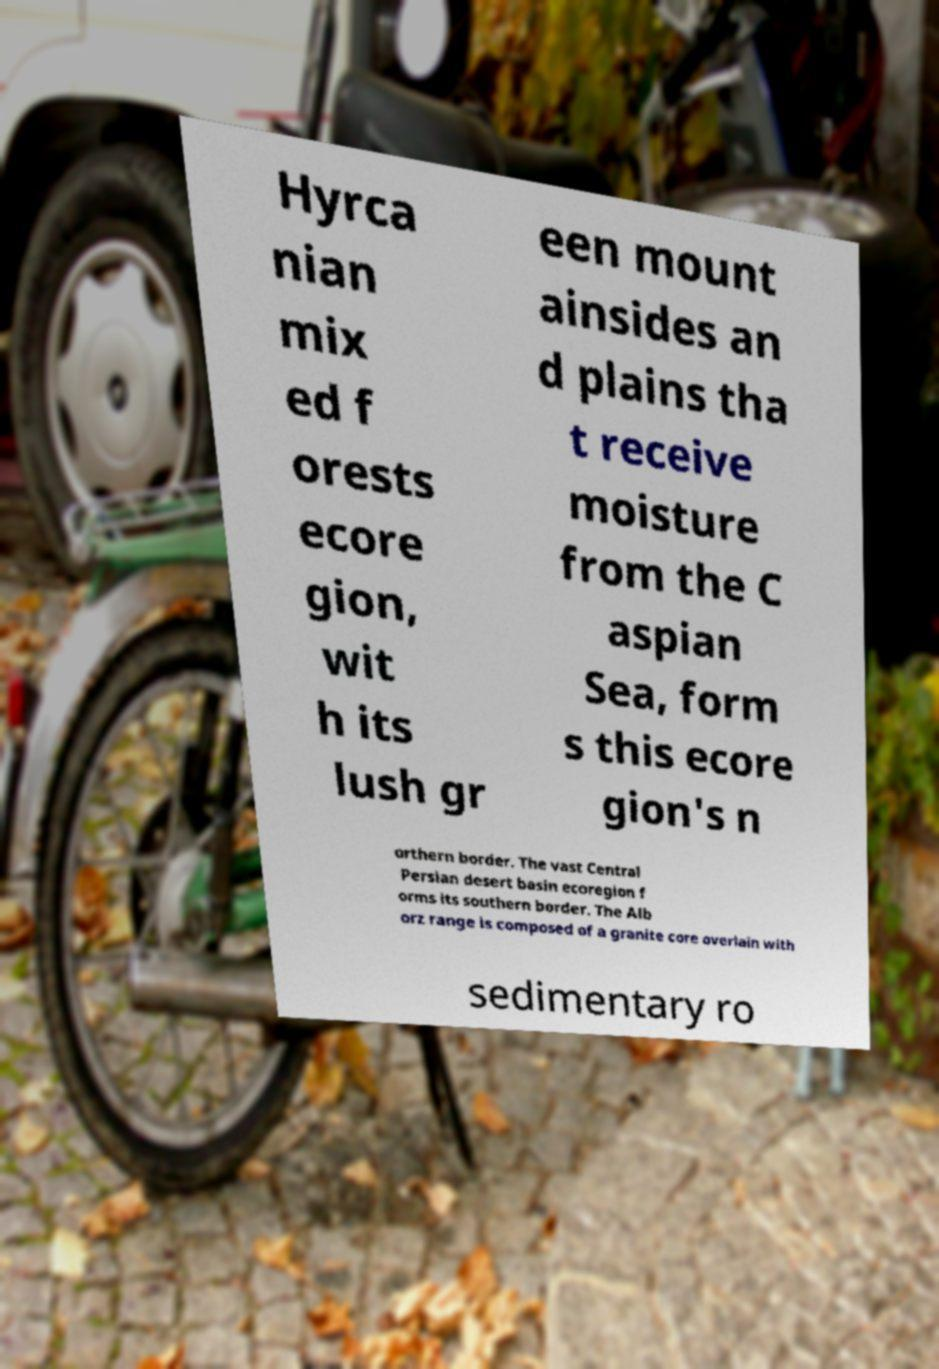Could you extract and type out the text from this image? Hyrca nian mix ed f orests ecore gion, wit h its lush gr een mount ainsides an d plains tha t receive moisture from the C aspian Sea, form s this ecore gion's n orthern border. The vast Central Persian desert basin ecoregion f orms its southern border. The Alb orz range is composed of a granite core overlain with sedimentary ro 